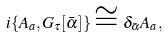<formula> <loc_0><loc_0><loc_500><loc_500>i \{ A _ { a } , G _ { \tau } [ \bar { \alpha } ] \} \cong \delta _ { \bar { \alpha } } A _ { a } ,</formula> 